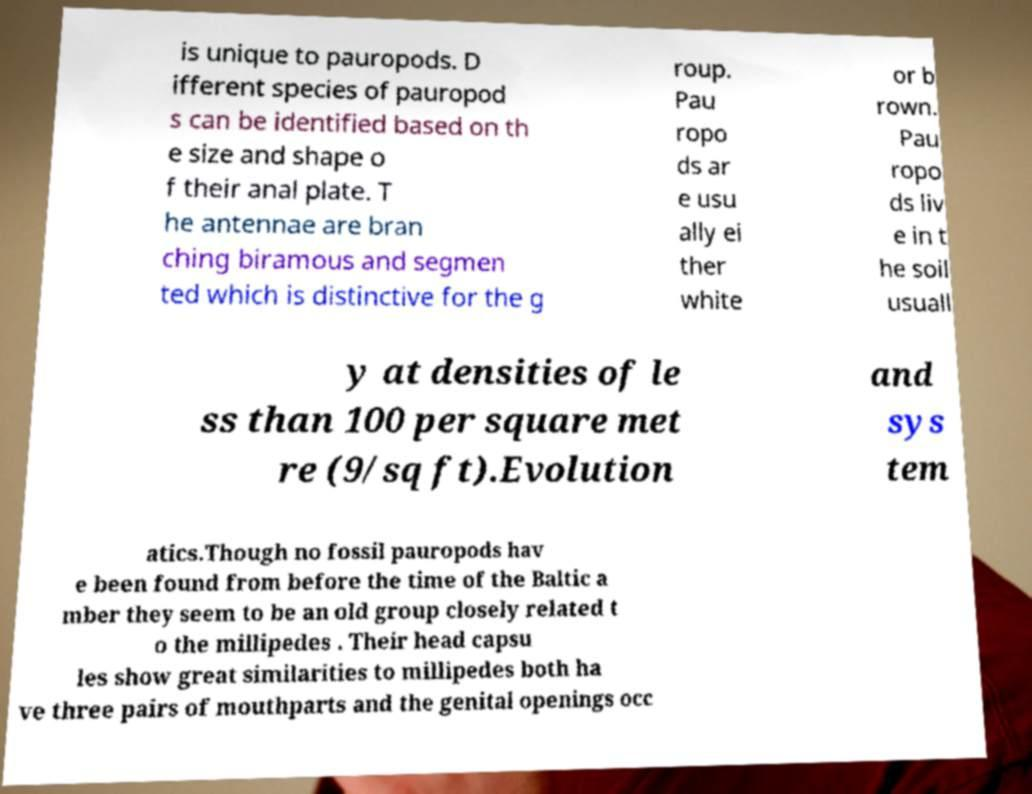Please identify and transcribe the text found in this image. is unique to pauropods. D ifferent species of pauropod s can be identified based on th e size and shape o f their anal plate. T he antennae are bran ching biramous and segmen ted which is distinctive for the g roup. Pau ropo ds ar e usu ally ei ther white or b rown. Pau ropo ds liv e in t he soil usuall y at densities of le ss than 100 per square met re (9/sq ft).Evolution and sys tem atics.Though no fossil pauropods hav e been found from before the time of the Baltic a mber they seem to be an old group closely related t o the millipedes . Their head capsu les show great similarities to millipedes both ha ve three pairs of mouthparts and the genital openings occ 